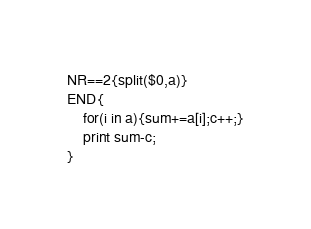<code> <loc_0><loc_0><loc_500><loc_500><_Awk_>NR==2{split($0,a)}
END{
	for(i in a){sum+=a[i];c++;}
    print sum-c;
}</code> 